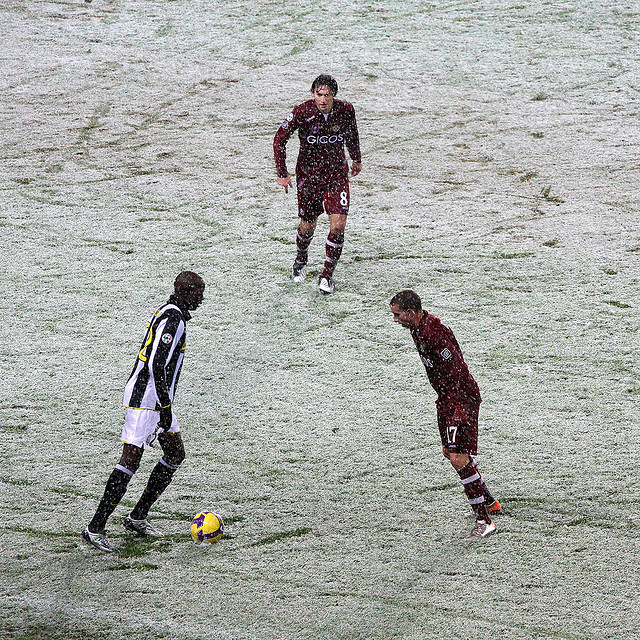Identify the text contained in this image. GICOS 8 